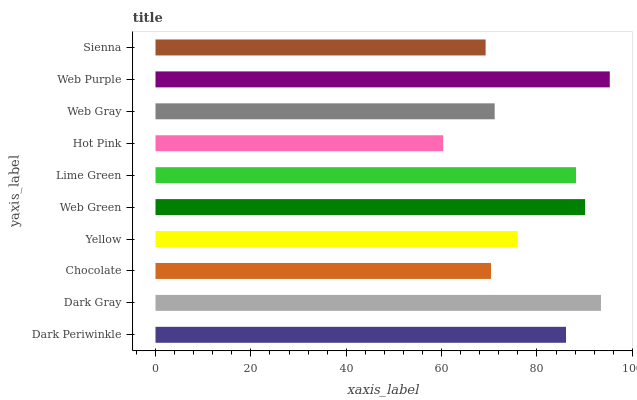Is Hot Pink the minimum?
Answer yes or no. Yes. Is Web Purple the maximum?
Answer yes or no. Yes. Is Dark Gray the minimum?
Answer yes or no. No. Is Dark Gray the maximum?
Answer yes or no. No. Is Dark Gray greater than Dark Periwinkle?
Answer yes or no. Yes. Is Dark Periwinkle less than Dark Gray?
Answer yes or no. Yes. Is Dark Periwinkle greater than Dark Gray?
Answer yes or no. No. Is Dark Gray less than Dark Periwinkle?
Answer yes or no. No. Is Dark Periwinkle the high median?
Answer yes or no. Yes. Is Yellow the low median?
Answer yes or no. Yes. Is Hot Pink the high median?
Answer yes or no. No. Is Web Purple the low median?
Answer yes or no. No. 